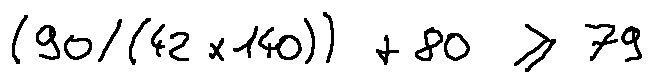<formula> <loc_0><loc_0><loc_500><loc_500>( 9 0 / ( 4 2 \times 1 4 0 ) ) + 8 0 \geq 7 9</formula> 